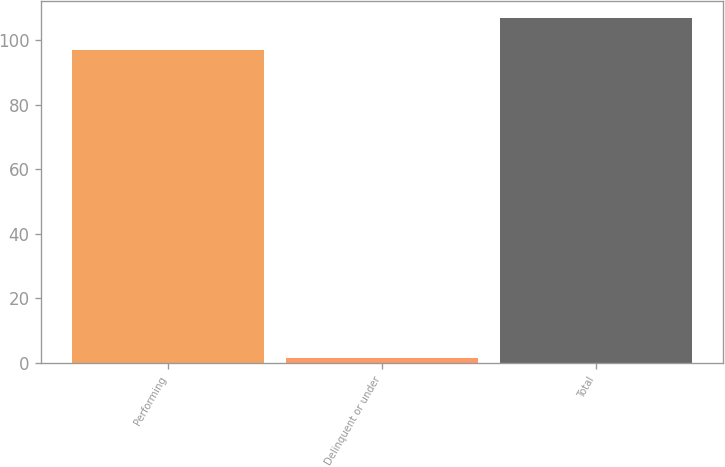Convert chart to OTSL. <chart><loc_0><loc_0><loc_500><loc_500><bar_chart><fcel>Performing<fcel>Delinquent or under<fcel>Total<nl><fcel>97.1<fcel>1.5<fcel>106.95<nl></chart> 